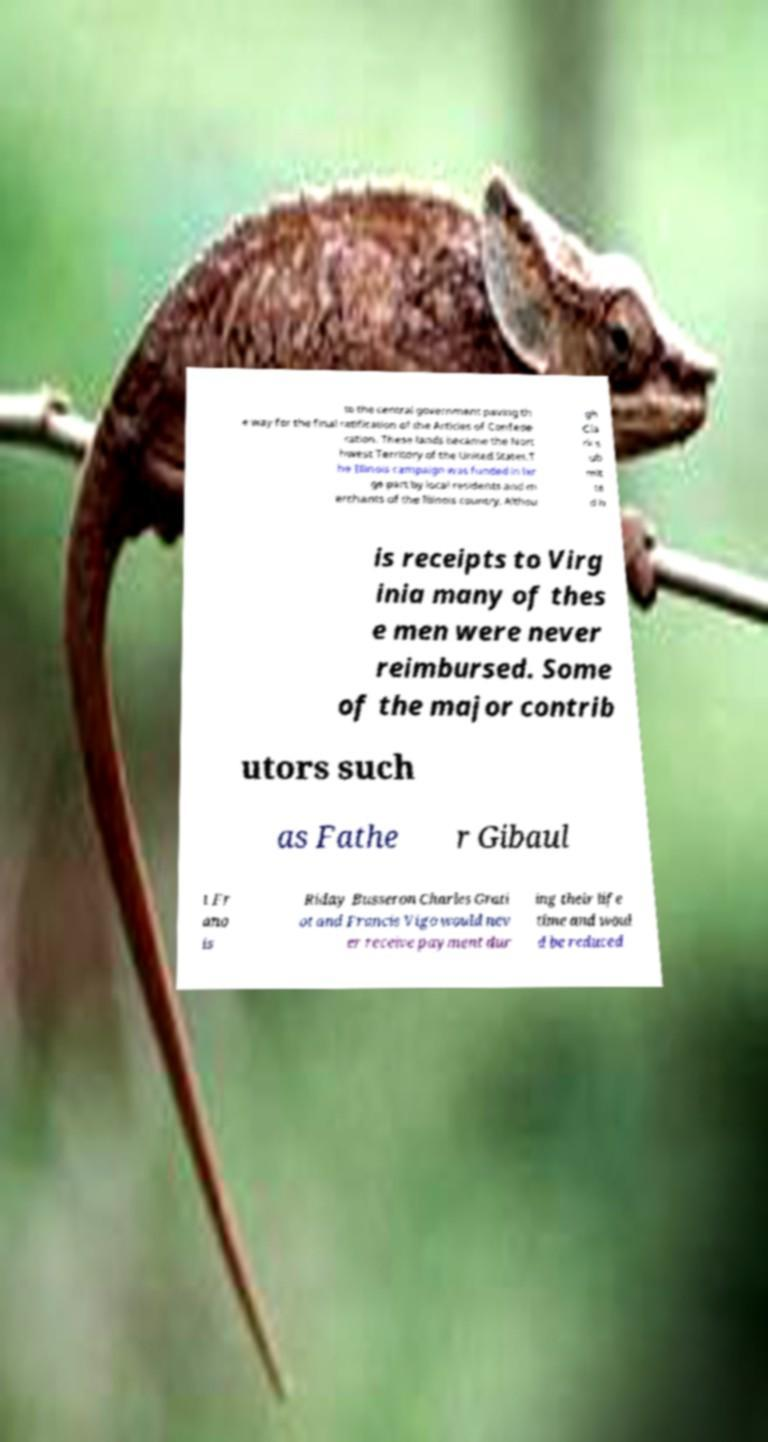Please read and relay the text visible in this image. What does it say? to the central government paving th e way for the final ratification of the Articles of Confede ration. These lands became the Nort hwest Territory of the United States.T he Illinois campaign was funded in lar ge part by local residents and m erchants of the Illinois country. Althou gh Cla rk s ub mit te d h is receipts to Virg inia many of thes e men were never reimbursed. Some of the major contrib utors such as Fathe r Gibaul t Fr ano is Riday Busseron Charles Grati ot and Francis Vigo would nev er receive payment dur ing their life time and woul d be reduced 